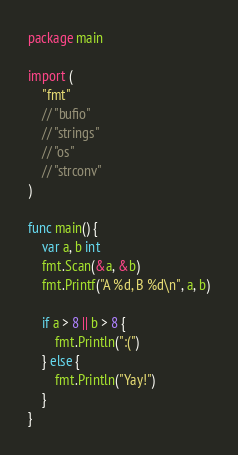Convert code to text. <code><loc_0><loc_0><loc_500><loc_500><_Go_>package main

import (
	"fmt"
	// "bufio"
	// "strings"
	// "os"
	// "strconv"
)

func main() {
	var a, b int
	fmt.Scan(&a, &b)
	fmt.Printf("A %d, B %d\n", a, b)

	if a > 8 || b > 8 {
		fmt.Println(":(")
	} else {
		fmt.Println("Yay!")
	}
}</code> 